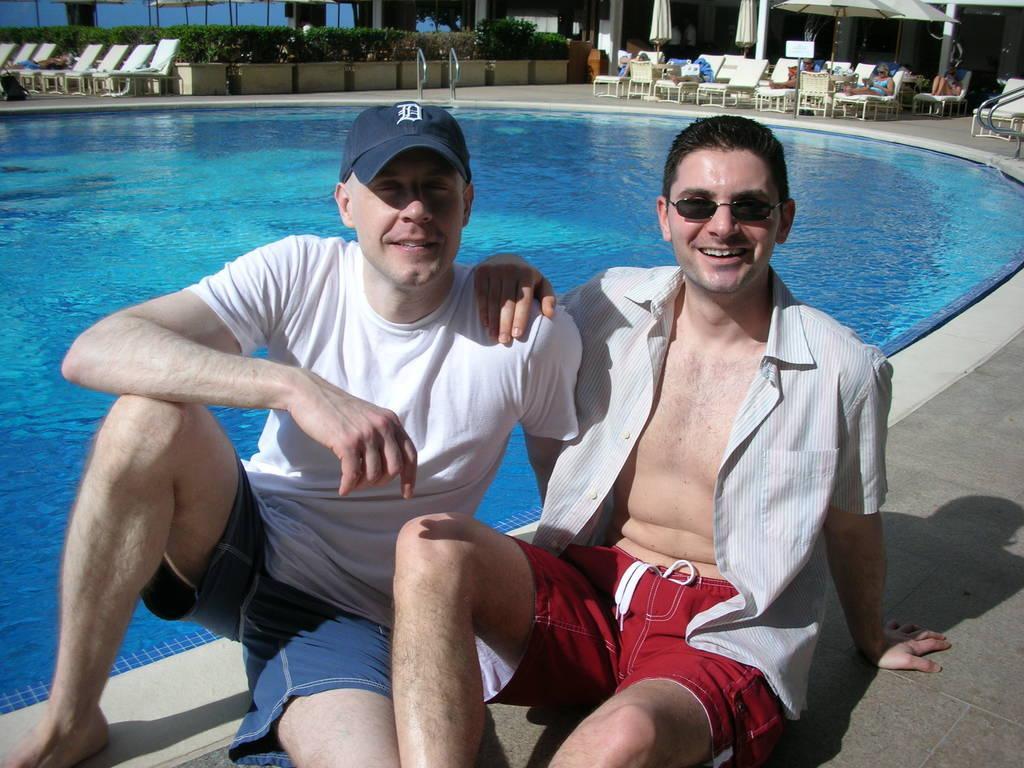Describe this image in one or two sentences. In this picture we can see two umbrellas. On the background of the picture we can see few hammock chairs with person's resting on it. Here we can see few plants with pots These are the hammock chairs. On the right side of the picture we can see a man, beside him there is another man. They both are sitting and giving a good still. This person is wearing spectacles. This person is wearing a cap. This is the shadow of the person. 